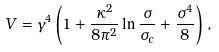<formula> <loc_0><loc_0><loc_500><loc_500>V = \gamma ^ { 4 } \left ( 1 + \frac { \kappa ^ { 2 } } { 8 \pi ^ { 2 } } \ln \frac { \sigma } { \sigma _ { c } } + \frac { \sigma ^ { 4 } } { 8 } \right ) \, ,</formula> 